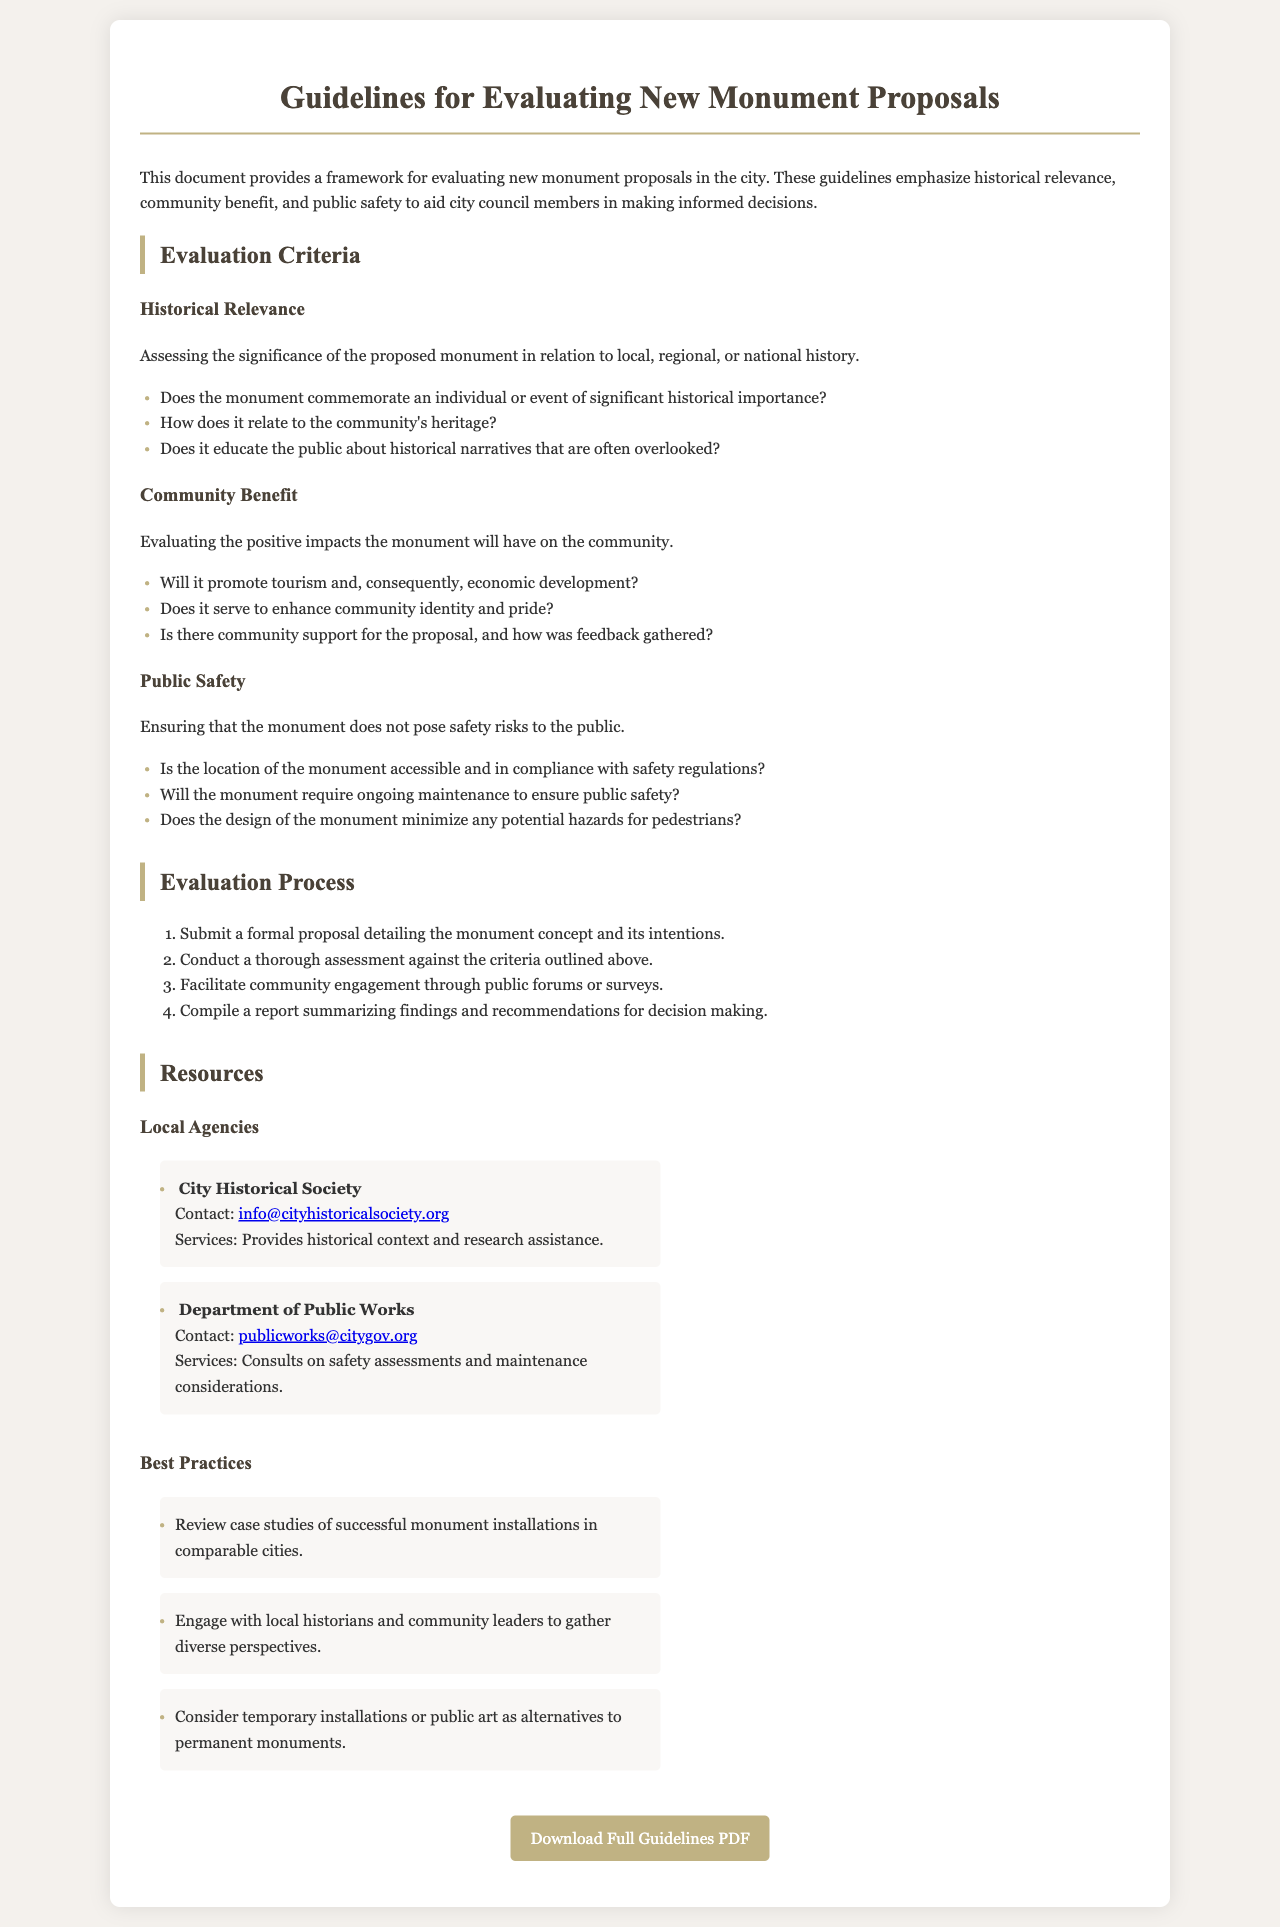What are the three main evaluation criteria for monument proposals? The document outlines three main evaluation criteria: Historical Relevance, Community Benefit, and Public Safety.
Answer: Historical Relevance, Community Benefit, Public Safety Who provides historical context and research assistance? The City Historical Society is mentioned as providing historical context and research assistance.
Answer: City Historical Society What should be included in the formal proposal for a monument? The proposal should detail the monument concept and its intentions as part of the submission process.
Answer: Monument concept and its intentions How many steps are in the evaluation process? The evaluation process consists of four steps, as listed in the document.
Answer: Four What type of engagement is suggested for community involvement? The document suggests facilitating community engagement through public forums or surveys.
Answer: Public forums or surveys What is one of the community benefits considered in the evaluation? The monument's potential to promote tourism and economic development is considered as a community benefit.
Answer: Promote tourism and economic development Which department consults on safety assessments? The Department of Public Works is the agency mentioned that consults on safety assessments.
Answer: Department of Public Works What does the evaluation criteria related to public safety assess? It assesses whether the monument's location is accessible and in compliance with safety regulations.
Answer: Accessible and in compliance with safety regulations 